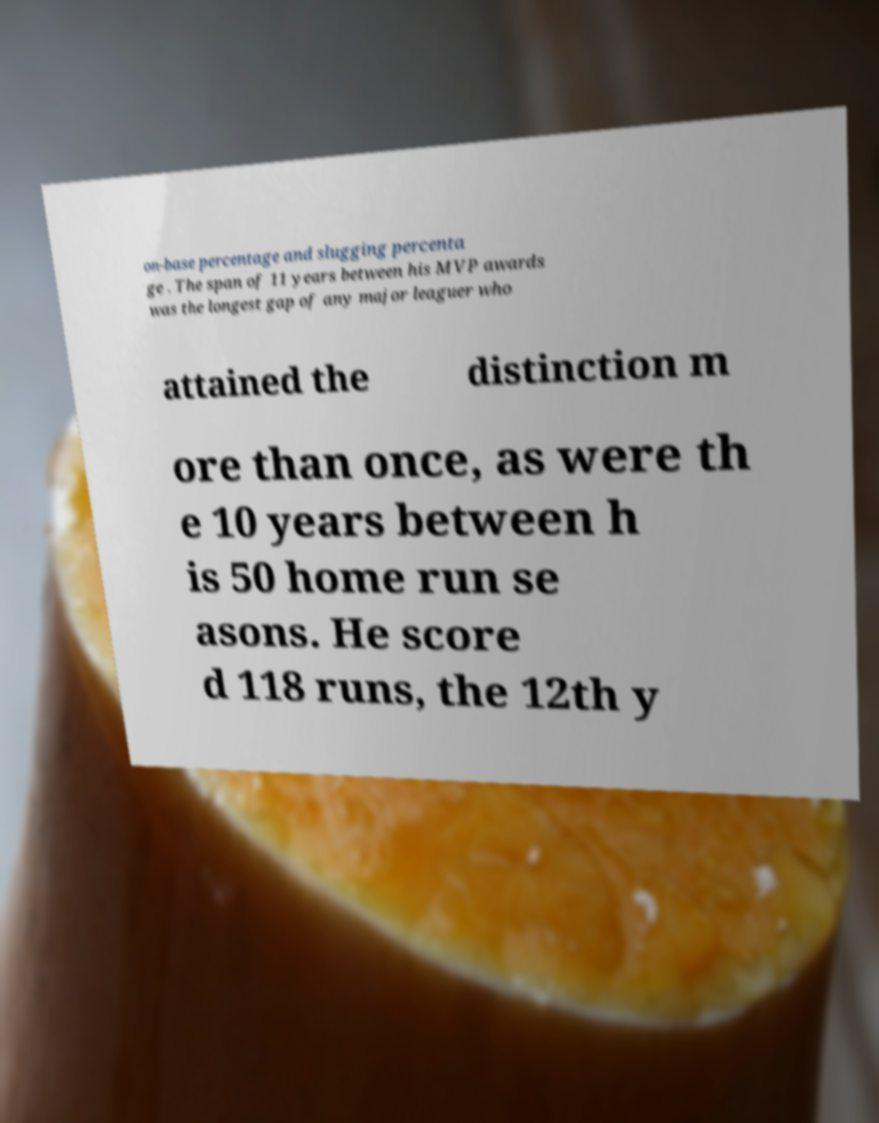Could you assist in decoding the text presented in this image and type it out clearly? on-base percentage and slugging percenta ge . The span of 11 years between his MVP awards was the longest gap of any major leaguer who attained the distinction m ore than once, as were th e 10 years between h is 50 home run se asons. He score d 118 runs, the 12th y 